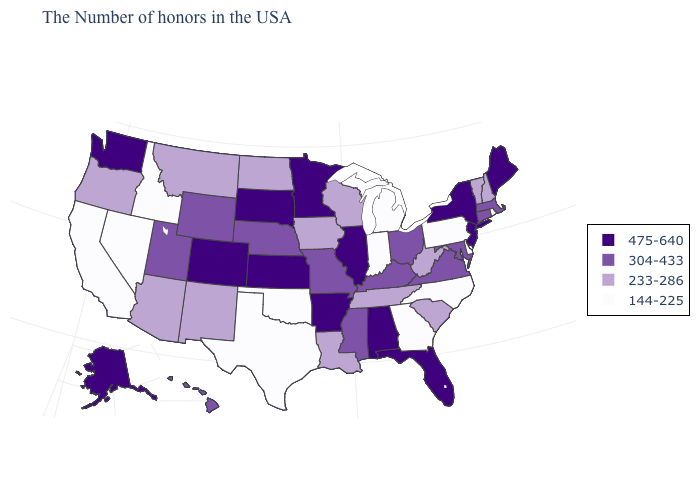What is the highest value in the USA?
Quick response, please. 475-640. What is the value of Maryland?
Quick response, please. 304-433. What is the value of Florida?
Quick response, please. 475-640. Does the map have missing data?
Answer briefly. No. Does Mississippi have a higher value than Minnesota?
Quick response, please. No. Among the states that border Kansas , does Colorado have the lowest value?
Short answer required. No. Name the states that have a value in the range 233-286?
Concise answer only. New Hampshire, Vermont, South Carolina, West Virginia, Tennessee, Wisconsin, Louisiana, Iowa, North Dakota, New Mexico, Montana, Arizona, Oregon. What is the lowest value in the USA?
Be succinct. 144-225. Name the states that have a value in the range 304-433?
Keep it brief. Massachusetts, Connecticut, Maryland, Virginia, Ohio, Kentucky, Mississippi, Missouri, Nebraska, Wyoming, Utah, Hawaii. What is the highest value in the USA?
Concise answer only. 475-640. What is the value of Wyoming?
Write a very short answer. 304-433. Does Alaska have the highest value in the USA?
Write a very short answer. Yes. Name the states that have a value in the range 475-640?
Be succinct. Maine, New York, New Jersey, Florida, Alabama, Illinois, Arkansas, Minnesota, Kansas, South Dakota, Colorado, Washington, Alaska. Which states have the lowest value in the West?
Give a very brief answer. Idaho, Nevada, California. 